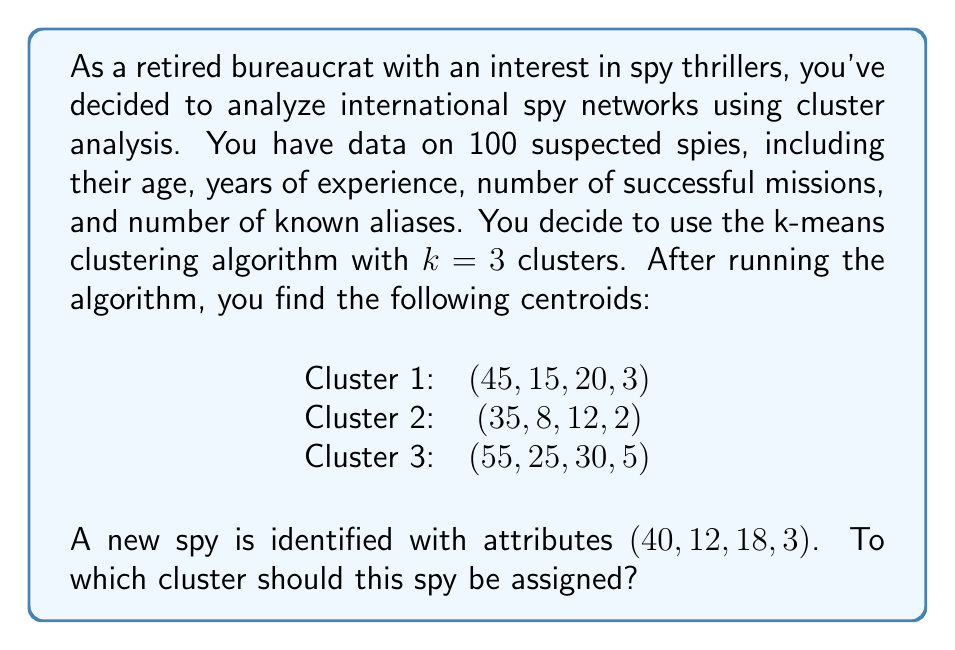Solve this math problem. To determine which cluster the new spy should be assigned to, we need to calculate the Euclidean distance between the spy's attributes and each cluster centroid. The cluster with the smallest distance will be the one to which the spy is assigned.

Let's calculate the distance to each centroid:

1. Distance to Cluster 1 centroid:
   $$d_1 = \sqrt{(40-45)^2 + (12-15)^2 + (18-20)^2 + (3-3)^2}$$
   $$d_1 = \sqrt{25 + 9 + 4 + 0} = \sqrt{38} \approx 6.16$$

2. Distance to Cluster 2 centroid:
   $$d_2 = \sqrt{(40-35)^2 + (12-8)^2 + (18-12)^2 + (3-2)^2}$$
   $$d_2 = \sqrt{25 + 16 + 36 + 1} = \sqrt{78} \approx 8.83$$

3. Distance to Cluster 3 centroid:
   $$d_3 = \sqrt{(40-55)^2 + (12-25)^2 + (18-30)^2 + (3-5)^2}$$
   $$d_3 = \sqrt{225 + 169 + 144 + 4} = \sqrt{542} \approx 23.28$$

The smallest distance is to Cluster 1 (6.16), so the new spy should be assigned to Cluster 1.
Answer: Cluster 1 